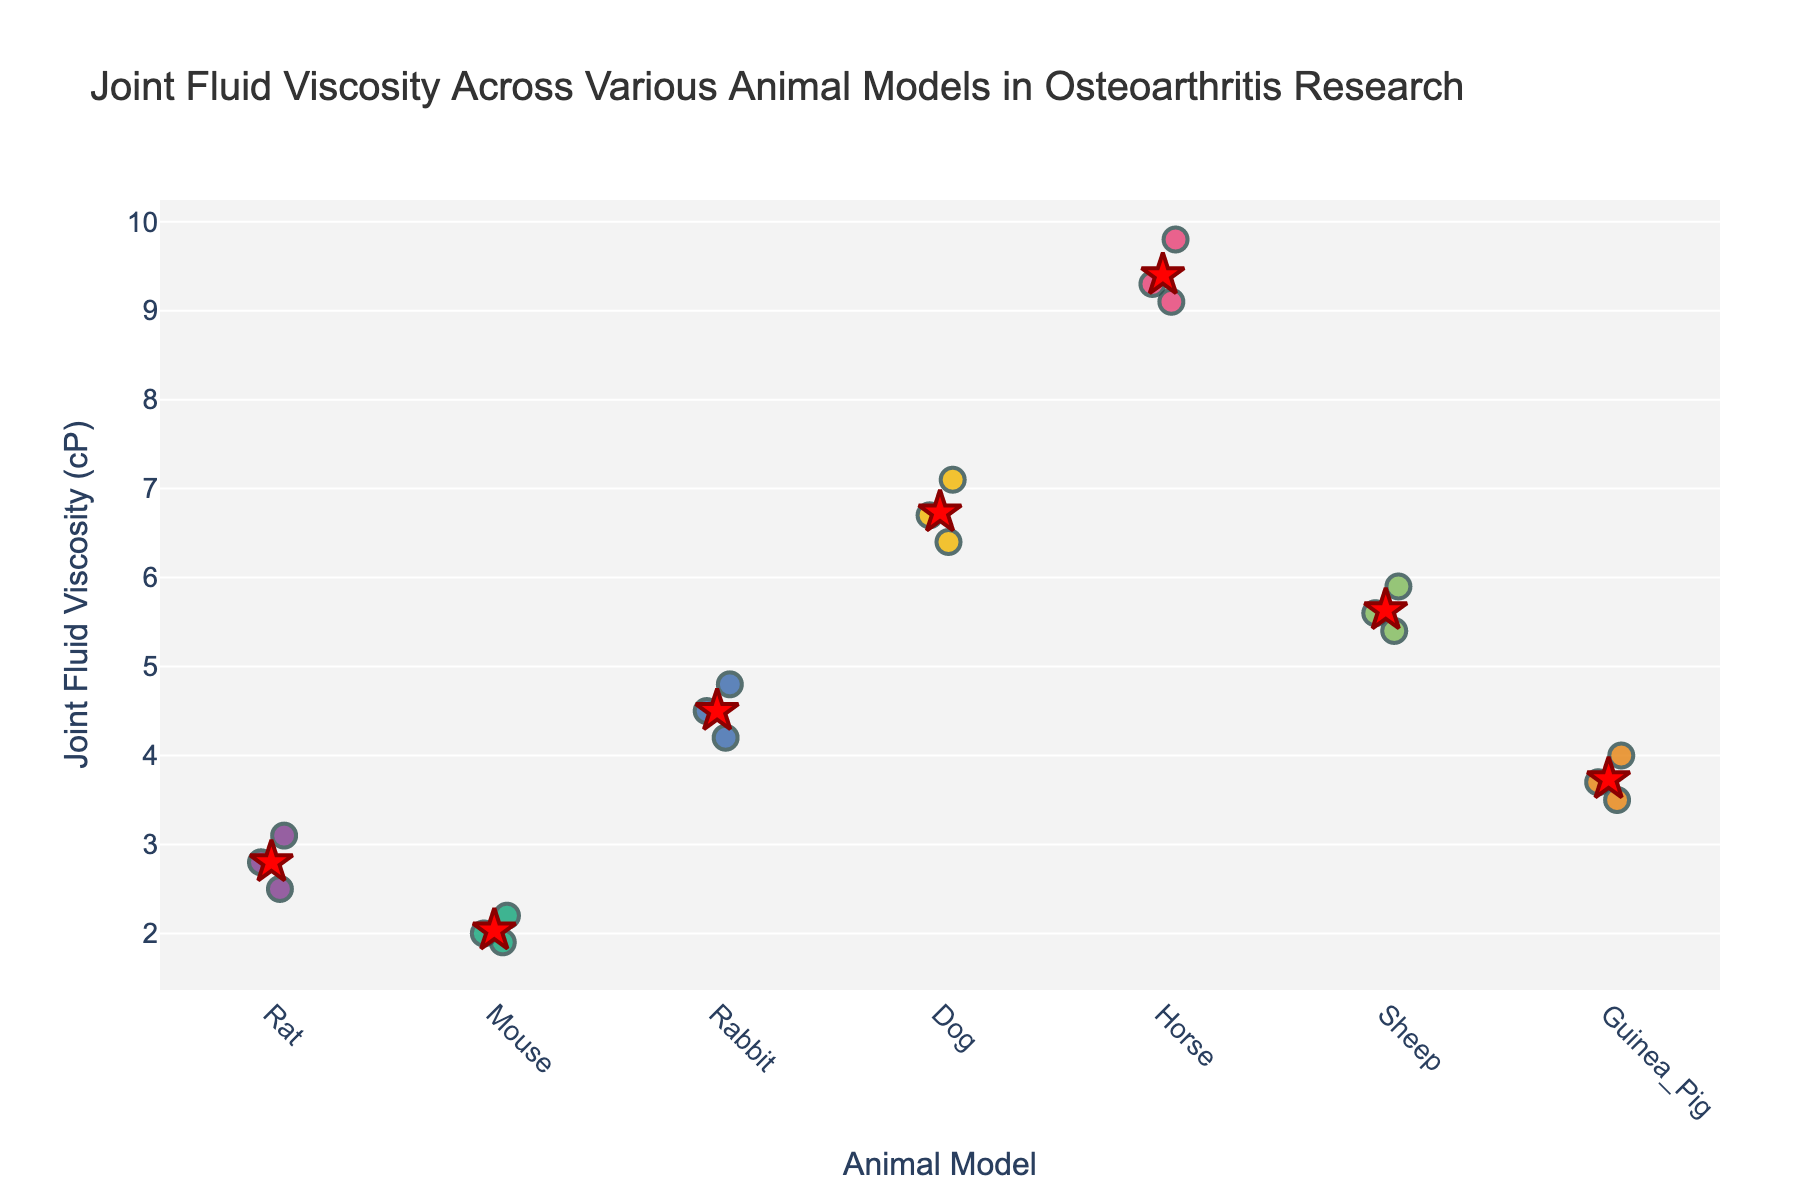How many different animal models are displayed? Count the distinct categories on the x-axis labeled "Animal Model." There are 7 distinct categories: Rat, Mouse, Rabbit, Dog, Horse, Sheep, Guinea Pig.
Answer: 7 Which animal model shows the highest joint fluid viscosity? Identify the animal model with the highest data points on the y-axis. The Horse model has the highest values around 9.8 cP.
Answer: Horse Which animal model has the lowest average joint fluid viscosity? Refer to the red stars that indicate the mean points for each model. The Mouse model has the lowest mean value.
Answer: Mouse What is the mean joint fluid viscosity for the Dog model? Locate the red star for the Dog model. It shows around 6.73 cP.
Answer: 6.73 cP Are the joint fluid viscosities for the Rat model higher or lower on average compared to the Rabbit model? Compare the mean points (red stars) of Rat and Rabbit models. The Rabbit’s mean is higher than the Rat’s mean.
Answer: Lower What is the range of joint fluid viscosity for the Guinea Pig model? Identify the minimum and maximum data points for the Guinea Pig model. The range is from 3.5 cP to 4.0 cP.
Answer: 3.5 to 4.0 cP Which animal model has the most spread in joint fluid viscosity values? Observe the spread of data points (vertical distance) for each model. The Horse model has the most spread.
Answer: Horse Is there any model with joint fluid viscosity values close to 5 cP? Identify if any model has data points near 5 cP. The Sheep model has values close to 5 cP.
Answer: Sheep Which two animal models have the closest mean joint fluid viscosities? Compare the red stars to find the closest mean values. Rat and Guinea Pig have means close to each other.
Answer: Rat and Guinea Pig How does the viscosity of the Rabbit model compare to the Mouse model? Look at both the individual data points and the mean points. The Rabbit model shows higher viscosity values and mean compared to the Mouse model.
Answer: Higher 